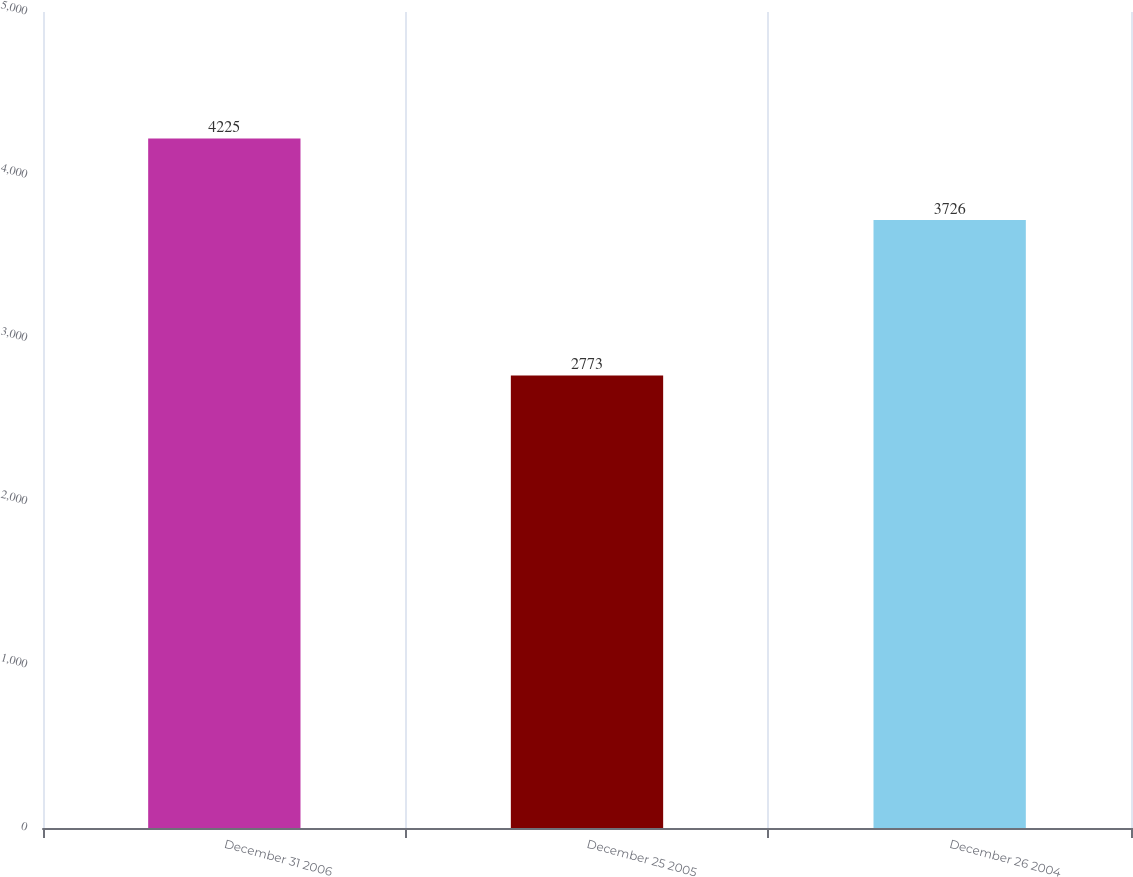<chart> <loc_0><loc_0><loc_500><loc_500><bar_chart><fcel>December 31 2006<fcel>December 25 2005<fcel>December 26 2004<nl><fcel>4225<fcel>2773<fcel>3726<nl></chart> 